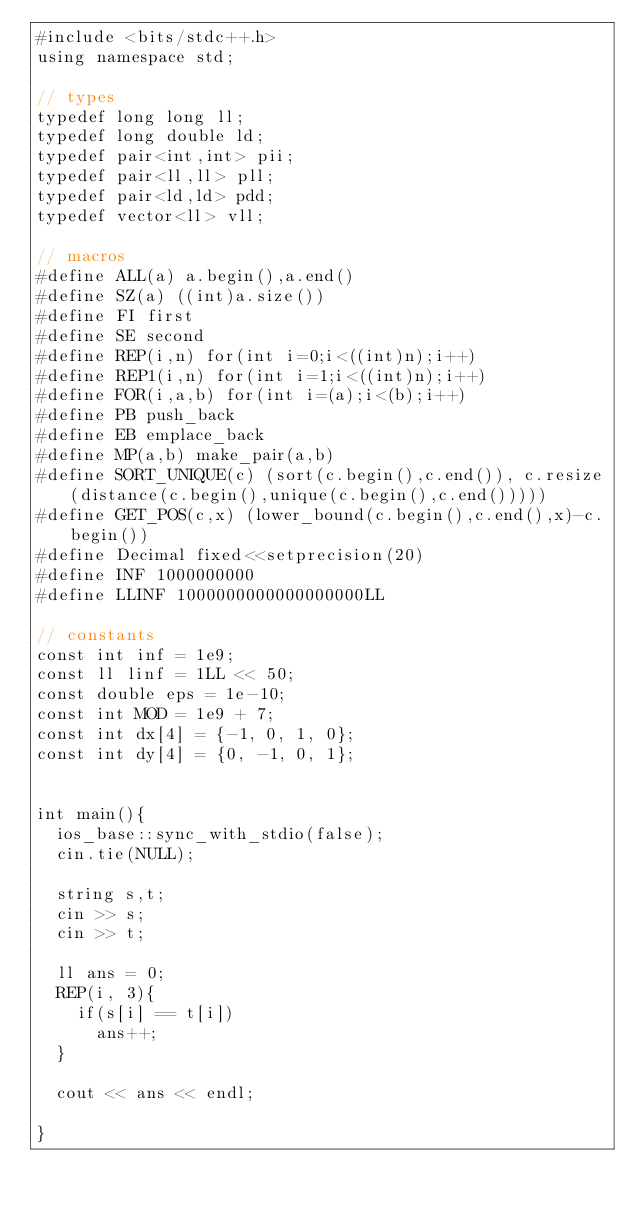Convert code to text. <code><loc_0><loc_0><loc_500><loc_500><_C++_>#include <bits/stdc++.h>
using namespace std;

// types
typedef long long ll;
typedef long double ld;
typedef pair<int,int> pii;
typedef pair<ll,ll> pll;
typedef pair<ld,ld> pdd;
typedef vector<ll> vll;

// macros
#define ALL(a) a.begin(),a.end()
#define SZ(a) ((int)a.size())
#define FI first
#define SE second
#define REP(i,n) for(int i=0;i<((int)n);i++)
#define REP1(i,n) for(int i=1;i<((int)n);i++)
#define FOR(i,a,b) for(int i=(a);i<(b);i++)
#define PB push_back
#define EB emplace_back
#define MP(a,b) make_pair(a,b)
#define SORT_UNIQUE(c) (sort(c.begin(),c.end()), c.resize(distance(c.begin(),unique(c.begin(),c.end()))))
#define GET_POS(c,x) (lower_bound(c.begin(),c.end(),x)-c.begin())
#define Decimal fixed<<setprecision(20)
#define INF 1000000000
#define LLINF 1000000000000000000LL

// constants
const int inf = 1e9;
const ll linf = 1LL << 50;
const double eps = 1e-10;
const int MOD = 1e9 + 7;
const int dx[4] = {-1, 0, 1, 0};
const int dy[4] = {0, -1, 0, 1};


int main(){
  ios_base::sync_with_stdio(false);
  cin.tie(NULL);

  string s,t;
  cin >> s;
  cin >> t;

  ll ans = 0;
  REP(i, 3){
    if(s[i] == t[i])
      ans++;
  }

  cout << ans << endl;
  
}
</code> 